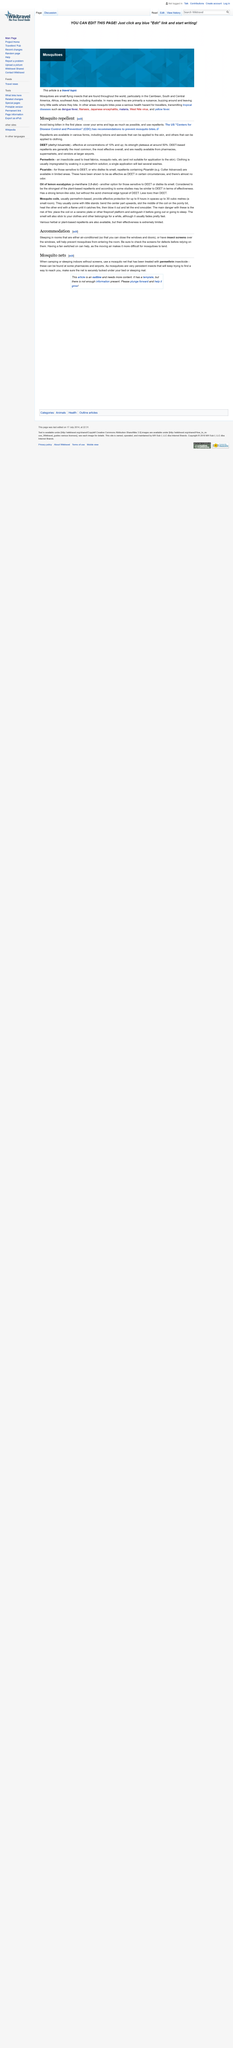Indicate a few pertinent items in this graphic. The first subheading is Accommodation, and it provides valuable information on the different types of accommodation available for tourists in Phuket. When camping or sleeping indoors without screens, it is recommended to use mosquito nets to protect against mosquito bites. What should you be sure to check? To check screens for defects and ensure they are functioning properly. 